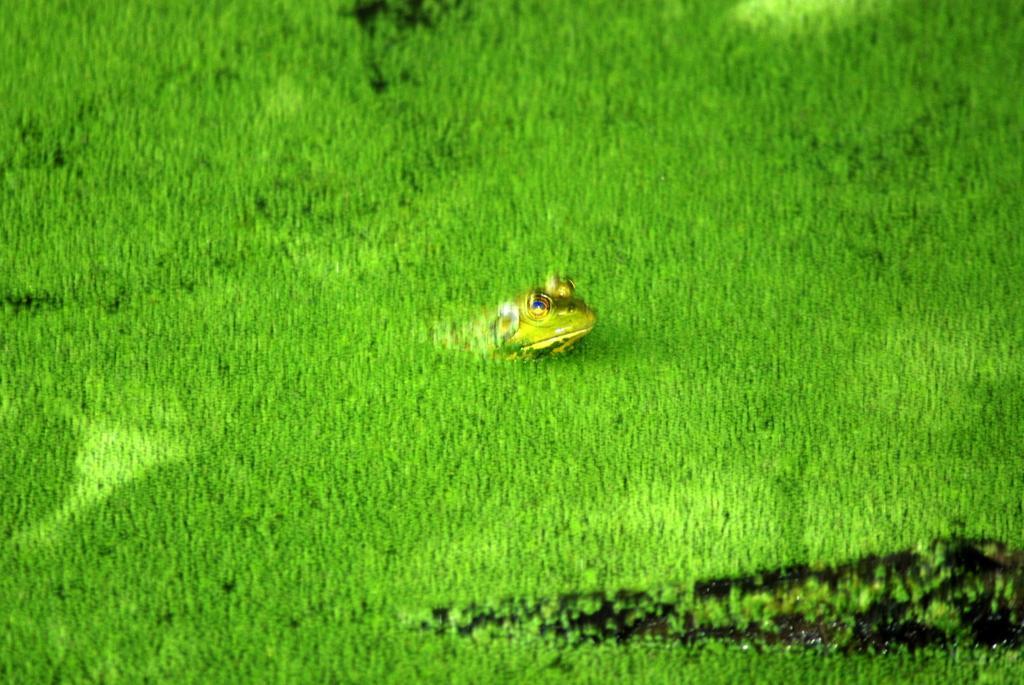How would you summarize this image in a sentence or two? There is a frog in the grasses. On the right side there is a black color thing. 